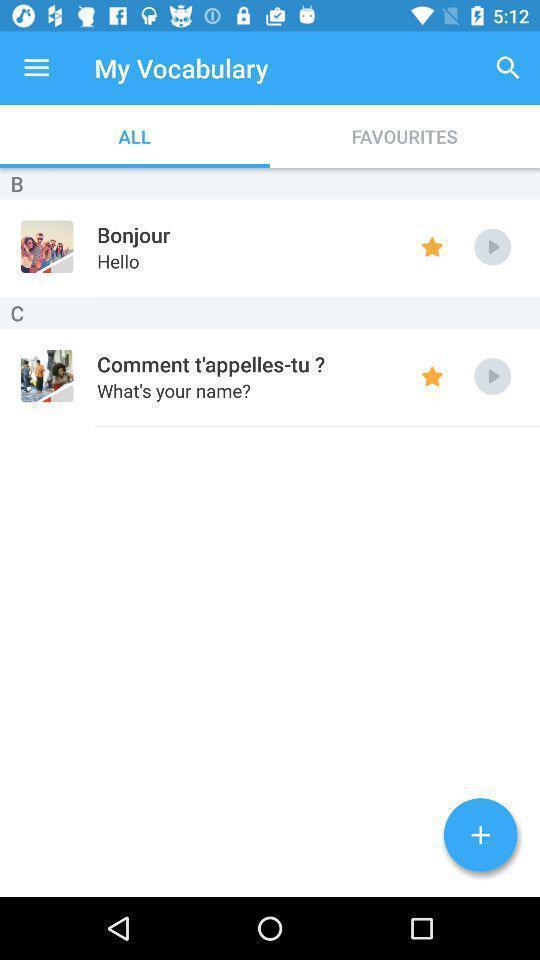What details can you identify in this image? Page showing list of vocabulary in the language learning app. 